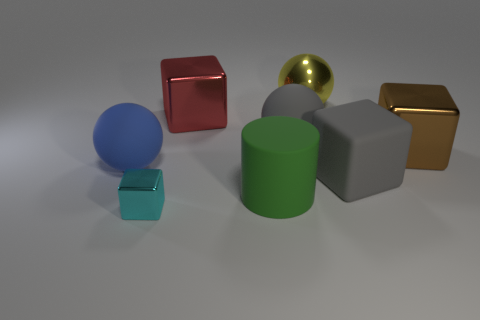Is there any other thing that is the same size as the cyan cube?
Your answer should be very brief. No. How many other things are there of the same material as the green thing?
Ensure brevity in your answer.  3. What number of things are yellow metallic spheres that are right of the big blue ball or blocks on the left side of the yellow ball?
Ensure brevity in your answer.  3. What material is the gray object that is the same shape as the large yellow metallic object?
Provide a succinct answer. Rubber. Are there any big gray matte blocks?
Your answer should be very brief. Yes. What is the size of the ball that is both in front of the red metal block and to the right of the large red object?
Give a very brief answer. Large. The brown metal object has what shape?
Keep it short and to the point. Cube. There is a big sphere that is to the left of the cyan shiny cube; are there any cyan metallic blocks to the right of it?
Your answer should be very brief. Yes. What material is the red cube that is the same size as the gray rubber ball?
Provide a succinct answer. Metal. Are there any gray rubber blocks that have the same size as the gray rubber sphere?
Your response must be concise. Yes. 